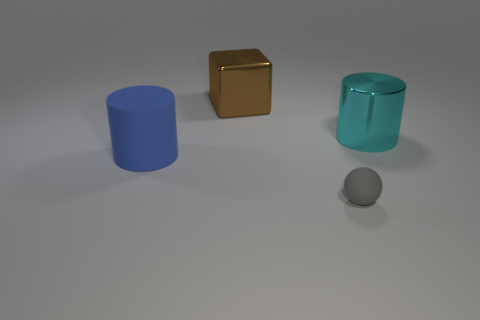Add 4 cyan shiny cylinders. How many objects exist? 8 Subtract all cubes. How many objects are left? 3 Add 4 cyan shiny cylinders. How many cyan shiny cylinders are left? 5 Add 2 blue rubber objects. How many blue rubber objects exist? 3 Subtract 0 green spheres. How many objects are left? 4 Subtract all blue cylinders. Subtract all cyan cylinders. How many objects are left? 2 